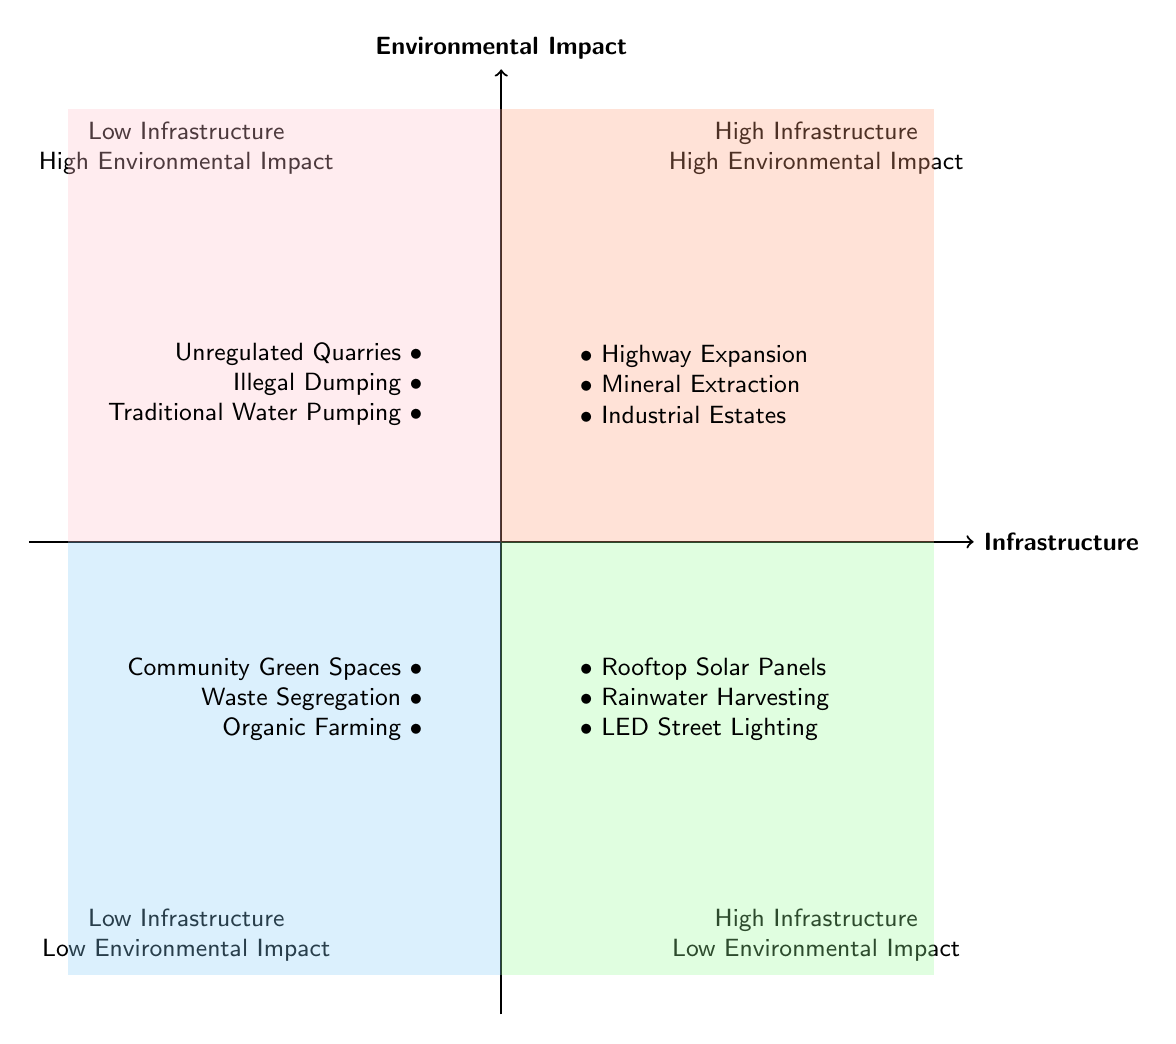What are some examples of projects in the "High Infrastructure - Low Environmental Impact" quadrant? The diagram indicates three projects in this quadrant: Rooftop Solar Panels, Rainwater Harvesting Systems, and LED Street Lighting.
Answer: Rooftop Solar Panels, Rainwater Harvesting Systems, LED Street Lighting How many projects are listed in the "Low Infrastructure - High Environmental Impact" quadrant? The quadrant contains three projects: Unregulated Local Quarries, Illegal Dumping Grounds, and Traditional Water Pumping Methods. Therefore, there are three projects total in this quadrant.
Answer: 3 Which quadrant contains Highway Expansion Projects? According to the diagram, Highway Expansion Projects are located in the "High Infrastructure - High Environmental Impact" quadrant.
Answer: High Infrastructure - High Environmental Impact What is the environmental impact level of "Community Green Spaces"? The diagram shows that Community Green Spaces fall under the "Low Infrastructure - Low Environmental Impact" quadrant, indicating a low environmental impact level.
Answer: Low Environmental Impact Which quadrant has projects that are high in both infrastructure and environmental impact? The diagram clearly specifies that the quadrant for high infrastructure and high environmental impact is labeled as "High Infrastructure - High Environmental Impact".
Answer: High Infrastructure - High Environmental Impact What type of projects are included in "Low Infrastructure - Low Environmental Impact"? The projects in this quadrant include Community Green Spaces, Waste Segregation Initiatives, and Organic Farming Programs, all reflecting low infrastructure and low environmental impact.
Answer: Community Green Spaces, Waste Segregation Initiatives, Organic Farming Programs In which quadrant will you find Industrial Estate Development? Industrial Estate Development is categorized in the "High Infrastructure - High Environmental Impact" quadrant according to the information in the diagram.
Answer: High Infrastructure - High Environmental Impact What is the main characteristic of the projects in the "Low Infrastructure - High Environmental Impact" quadrant? This quadrant features projects that contribute to significant environmental harm despite having low infrastructure, such as Unregulated Local Quarries.
Answer: Significant environmental harm Which quadrant represents a balance between infrastructure development and environmental responsibility? The "High Infrastructure - Low Environmental Impact" quadrant indicates a balance by featuring projects that enhance infrastructure while minimizing environmental concerns.
Answer: High Infrastructure - Low Environmental Impact 